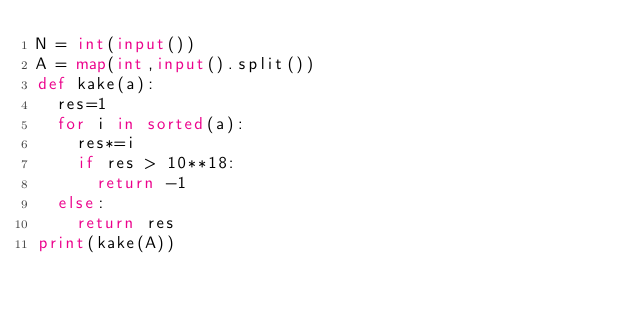<code> <loc_0><loc_0><loc_500><loc_500><_Python_>N = int(input())
A = map(int,input().split())
def kake(a):
  res=1
  for i in sorted(a):
    res*=i
    if res > 10**18:
      return -1
  else:
    return res
print(kake(A))</code> 